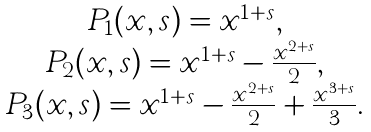Convert formula to latex. <formula><loc_0><loc_0><loc_500><loc_500>\begin{array} { c } P _ { 1 } ( x , s ) = x ^ { 1 + s } , \\ P _ { 2 } ( x , s ) = x ^ { 1 + s } - \frac { x ^ { 2 + s } } 2 , \\ P _ { 3 } ( x , s ) = x ^ { 1 + s } - \frac { x ^ { 2 + s } } 2 + \frac { x ^ { 3 + s } } 3 . \end{array}</formula> 